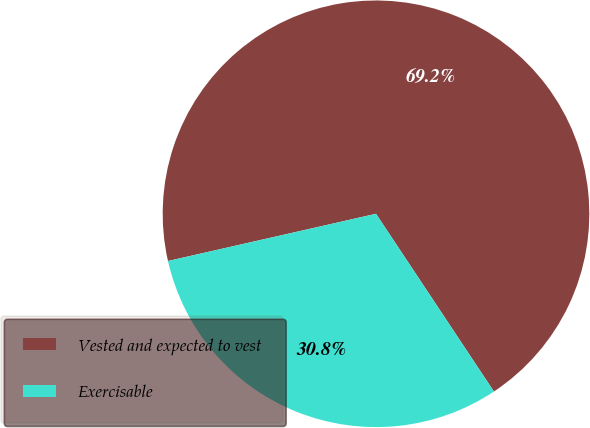<chart> <loc_0><loc_0><loc_500><loc_500><pie_chart><fcel>Vested and expected to vest<fcel>Exercisable<nl><fcel>69.23%<fcel>30.77%<nl></chart> 